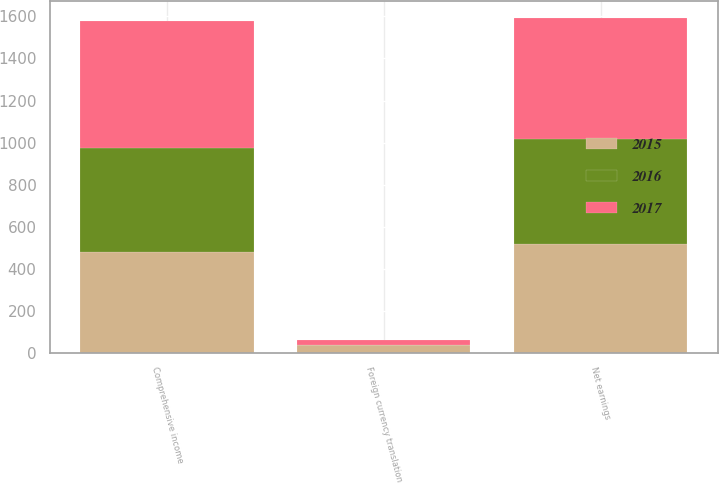Convert chart. <chart><loc_0><loc_0><loc_500><loc_500><stacked_bar_chart><ecel><fcel>Net earnings<fcel>Foreign currency translation<fcel>Comprehensive income<nl><fcel>2017<fcel>578.6<fcel>22.2<fcel>600.8<nl><fcel>2016<fcel>499.4<fcel>0.9<fcel>498.5<nl><fcel>2015<fcel>516.4<fcel>38.6<fcel>477.8<nl></chart> 